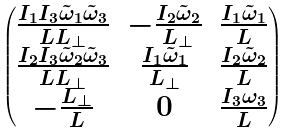<formula> <loc_0><loc_0><loc_500><loc_500>\begin{pmatrix} \frac { I _ { 1 } I _ { 3 } \tilde { \omega } _ { 1 } \tilde { \omega } _ { 3 } } { L L _ { \perp } } & - \frac { I _ { 2 } \tilde { \omega } _ { 2 } } { L _ { \perp } } & \frac { I _ { 1 } \tilde { \omega } _ { 1 } } { L } \\ \frac { I _ { 2 } I _ { 3 } \tilde { \omega } _ { 2 } \tilde { \omega } _ { 3 } } { L L _ { \perp } } & \frac { I _ { 1 } \tilde { \omega } _ { 1 } } { L _ { \perp } } & \frac { I _ { 2 } \tilde { \omega } _ { 2 } } { L } \\ - \frac { L _ { \perp } } { L } & 0 & \frac { I _ { 3 } \omega _ { 3 } } { L } \end{pmatrix}</formula> 